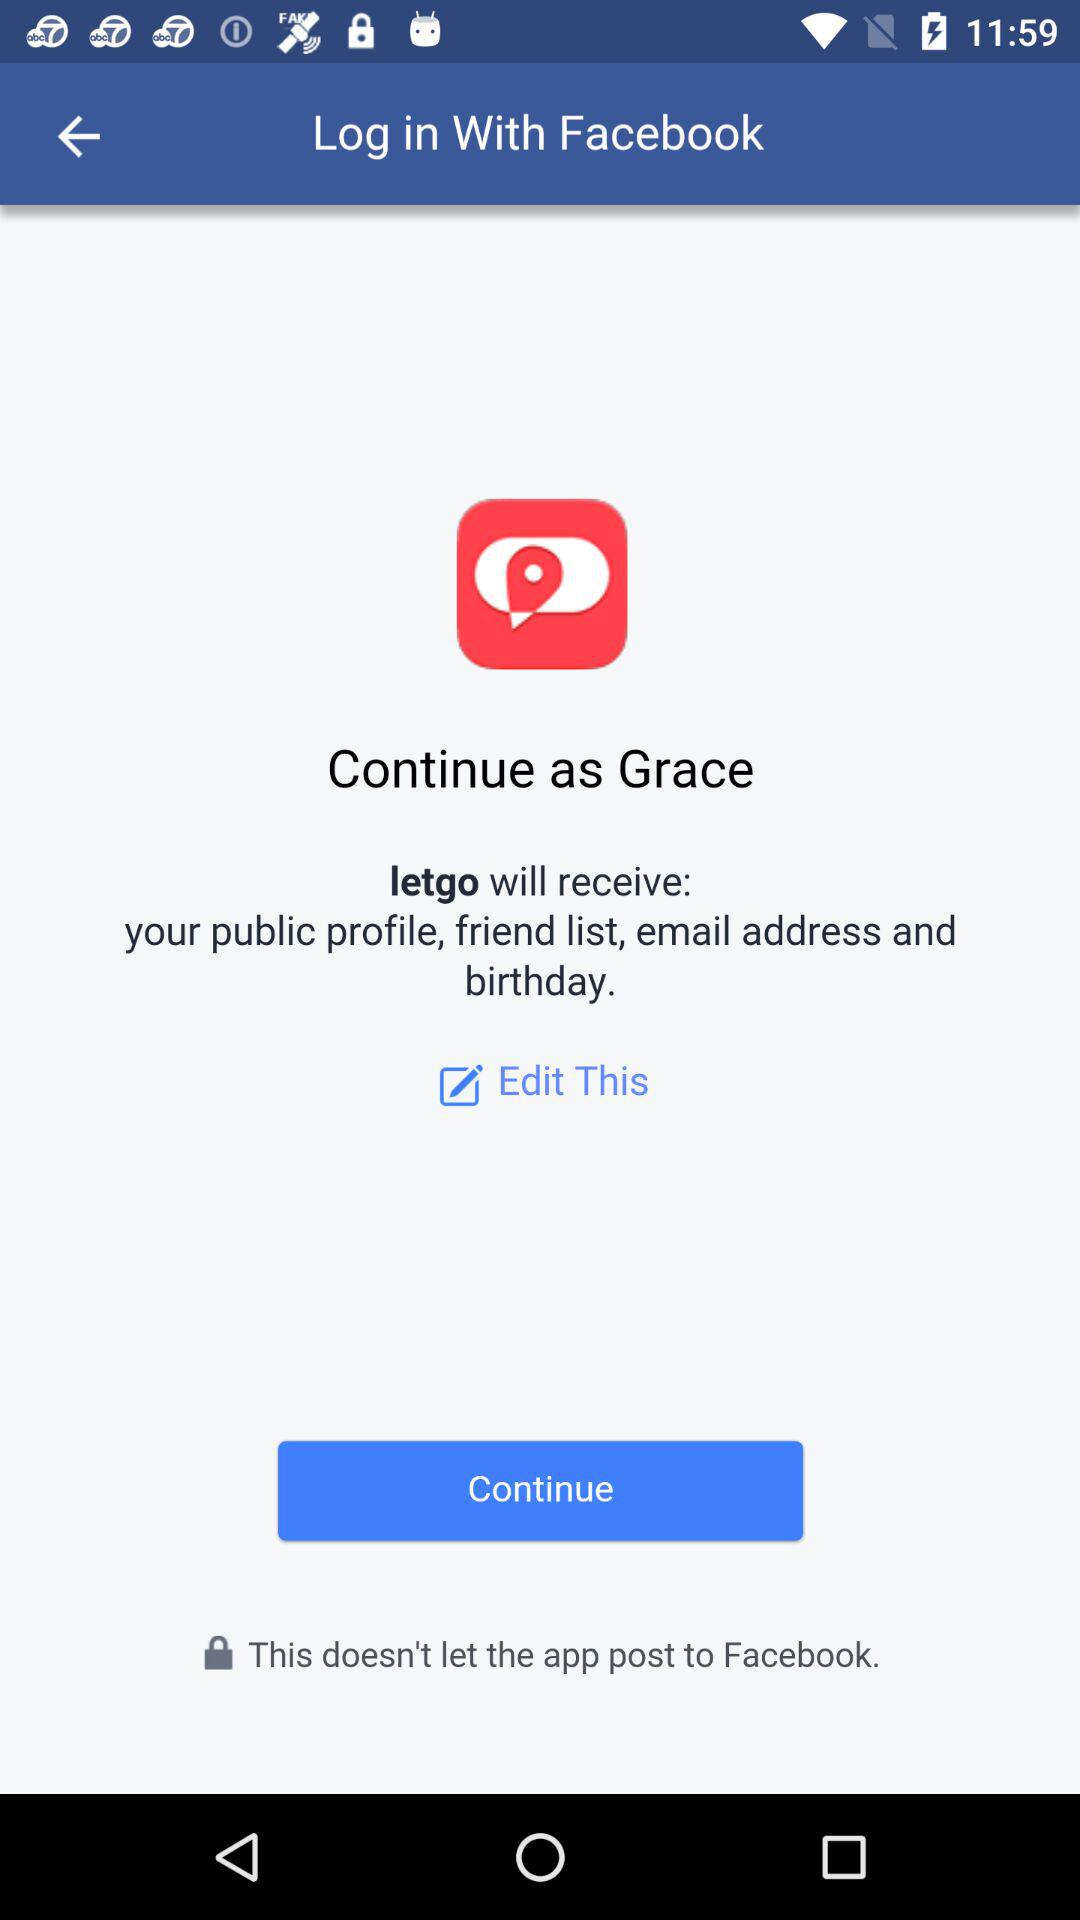What application is asking for permission? The application asking for permission is "letgo". 